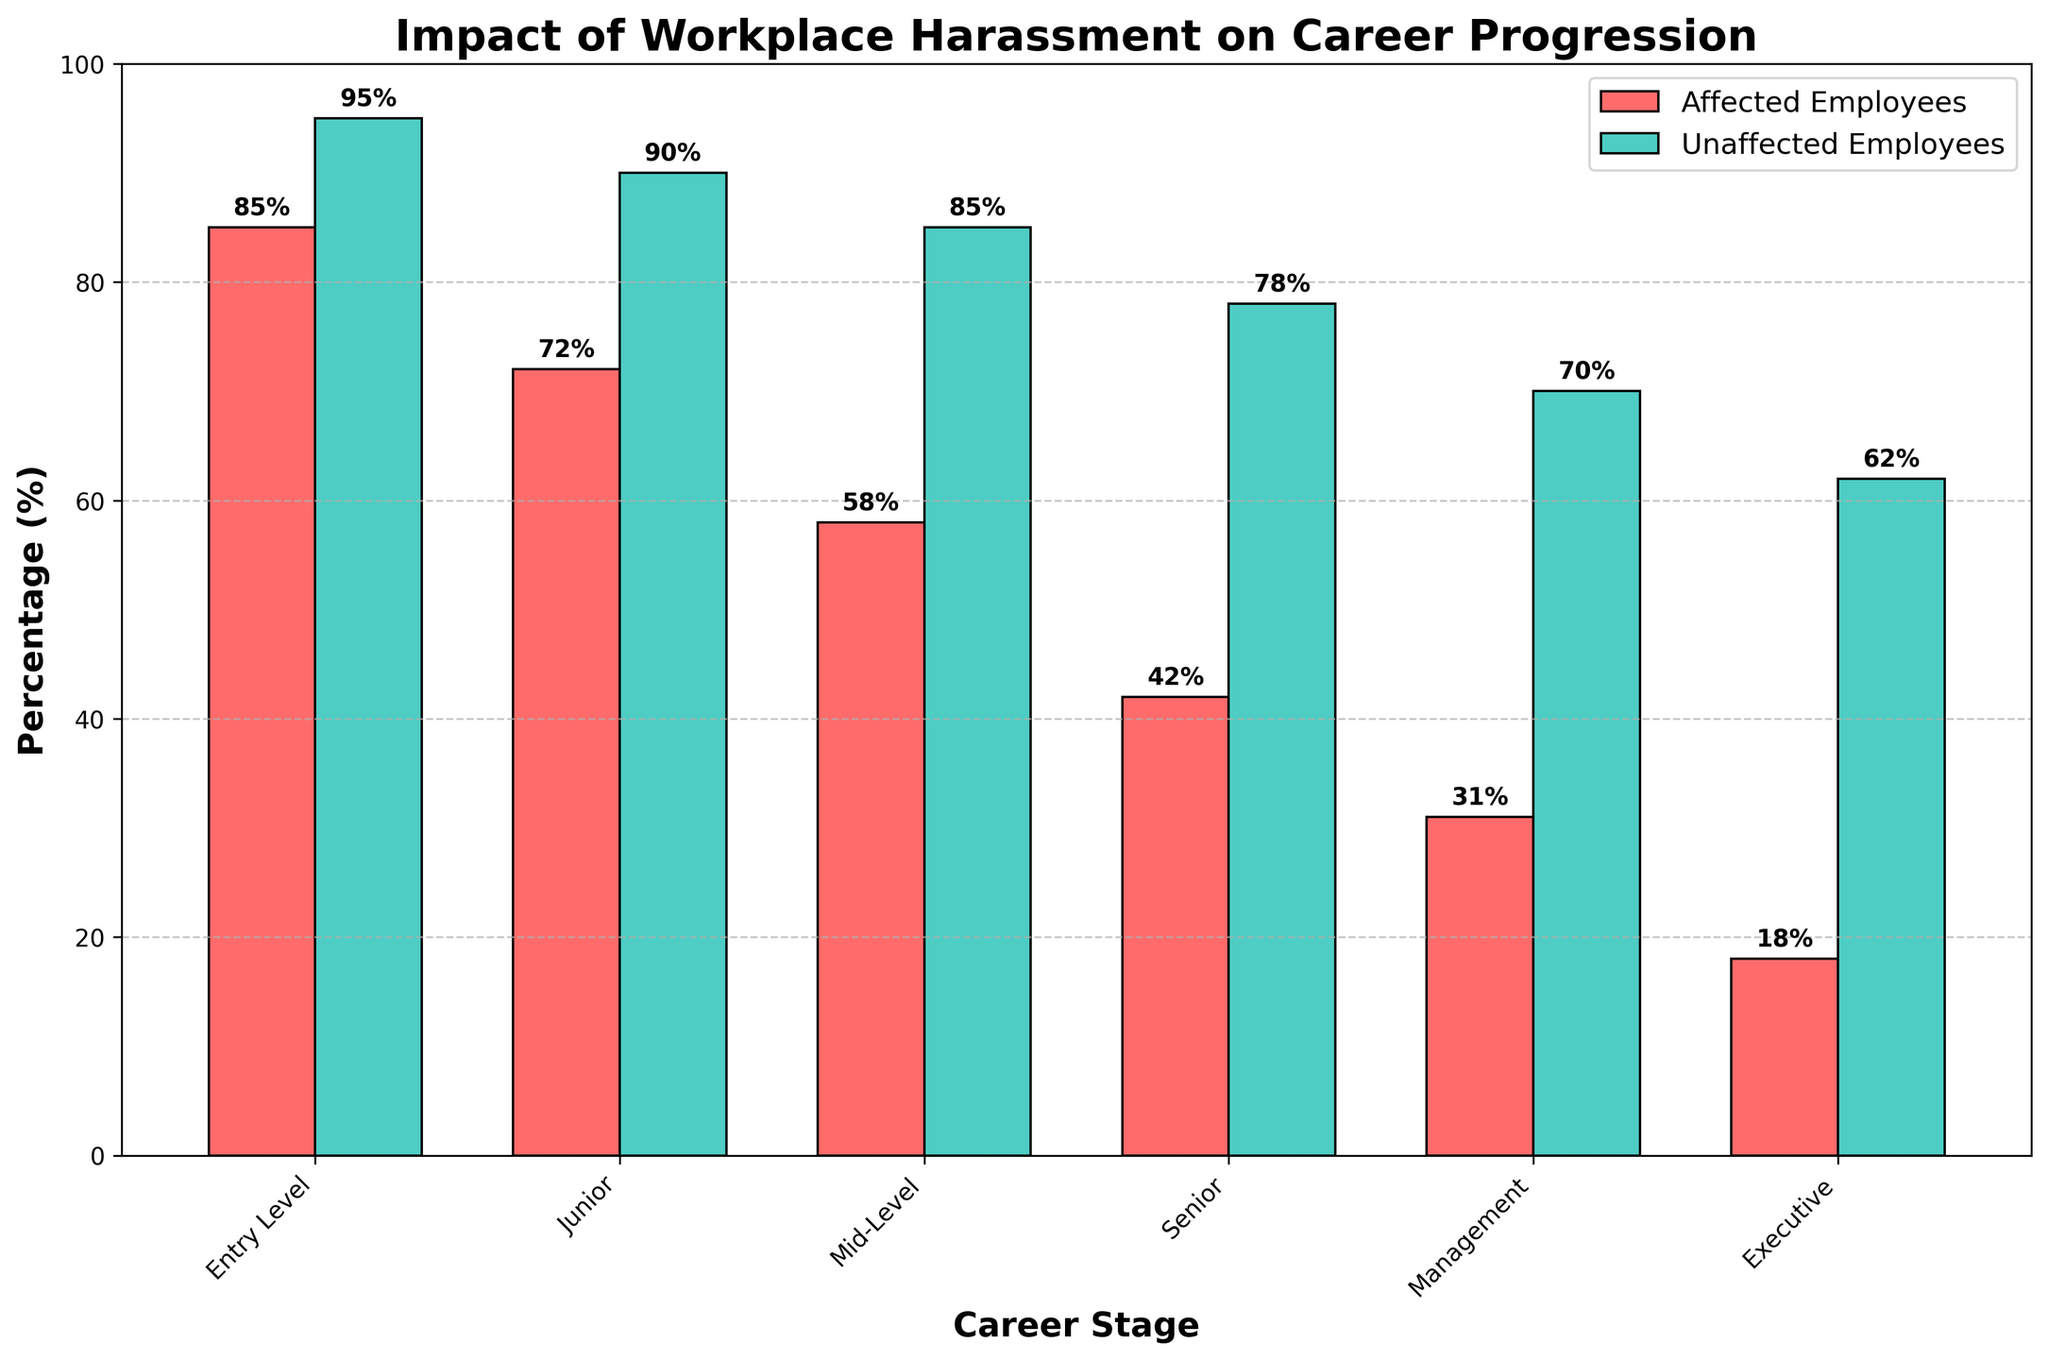Which career stage has the highest percentage of affected employees? The highest bar among affected employees is in the Entry Level stage, which shows the highest percentage.
Answer: Entry Level What is the difference in percentage between affected and unaffected employees at the Executive level? The percentage of affected employees at the Executive level is 18% and for unaffected employees is 62%. The difference is calculated as 62% - 18%.
Answer: 44% Are there more affected or unaffected employees at the Mid-Level stage? By comparing the heights of the bars for affected and unaffected employees at the Mid-Level stage, we see that unaffected employees have a higher percentage (85% vs. 58%).
Answer: Unaffected employees Which group has a lower percentage at the Senior level, affected or unaffected employees? The bar for affected employees at the Senior level is lower than the bar for unaffected employees (42% vs. 78%).
Answer: Affected employees What is the sum of the percentages of affected and unaffected employees at the Management level? The percentage of affected employees at Management level is 31% and for unaffected employees is 70%. The sum is calculated as 31% + 70%.
Answer: 101% How does the percentage of affected employees at the Junior level compare to those at the Senior level? The bar for affected employees at the Junior level shows 72%, while the Senior level shows 42%. Thus, the Junior level has a higher percentage of affected employees.
Answer: Higher What is the average percentage of unaffected employees across all career stages? The percentages for unaffected employees are: 95, 90, 85, 78, 70, 62. The average is calculated as (95 + 90 + 85 + 78 + 70 + 62) / 6.
Answer: 80% What percentage of affected employees are at the Entry Level stage in comparison to the highest percentage of unaffected employees? The percentage of affected employees at the Entry Level is 85%, and the highest percentage of unaffected employees is also at the Entry Level (95%). This indicates that the Entry Level has a relatively high percentage for both groups.
Answer: 85% vs. 95% Is the percentage of unaffected employees at the Mid-Level stage greater than the sum of affected employees at both the Entry Level and Executive stages? The percentage of unaffected employees at the Mid-Level stage is 85%. The sum of affected employees at the Entry Level (85%) and Executive stages (18%) is 85% + 18% = 103%. 85% is less than 103%.
Answer: No Which visual attribute differentiates the bars representing affected and unaffected employees? The bars representing affected employees are colored red, while the bars for unaffected employees are colored green, providing a clear visual distinction between the two groups.
Answer: Color 